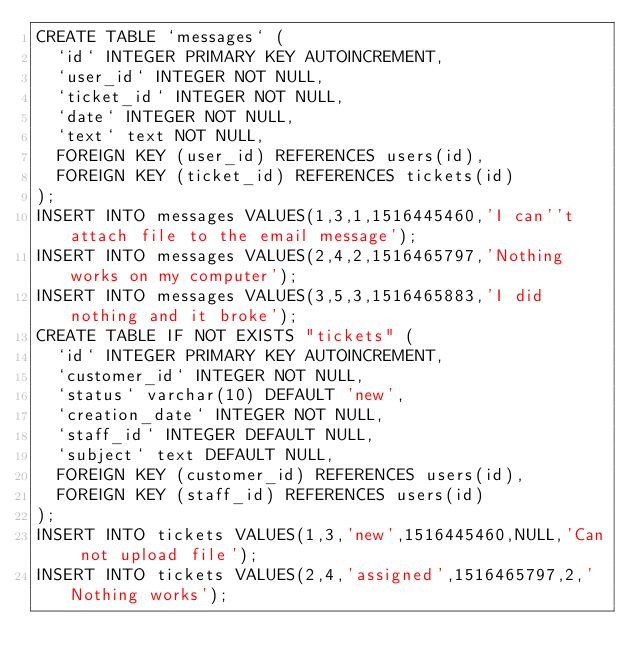Convert code to text. <code><loc_0><loc_0><loc_500><loc_500><_SQL_>CREATE TABLE `messages` (
  `id` INTEGER PRIMARY KEY AUTOINCREMENT,
  `user_id` INTEGER NOT NULL,
  `ticket_id` INTEGER NOT NULL,
  `date` INTEGER NOT NULL,
  `text` text NOT NULL,
  FOREIGN KEY (user_id) REFERENCES users(id),
  FOREIGN KEY (ticket_id) REFERENCES tickets(id)
);
INSERT INTO messages VALUES(1,3,1,1516445460,'I can''t attach file to the email message');
INSERT INTO messages VALUES(2,4,2,1516465797,'Nothing works on my computer');
INSERT INTO messages VALUES(3,5,3,1516465883,'I did nothing and it broke');
CREATE TABLE IF NOT EXISTS "tickets" (
  `id` INTEGER PRIMARY KEY AUTOINCREMENT,
  `customer_id` INTEGER NOT NULL,
  `status` varchar(10) DEFAULT 'new',
  `creation_date` INTEGER NOT NULL,
  `staff_id` INTEGER DEFAULT NULL,
  `subject` text DEFAULT NULL,
  FOREIGN KEY (customer_id) REFERENCES users(id),
  FOREIGN KEY (staff_id) REFERENCES users(id)
);
INSERT INTO tickets VALUES(1,3,'new',1516445460,NULL,'Can not upload file');
INSERT INTO tickets VALUES(2,4,'assigned',1516465797,2,'Nothing works');</code> 